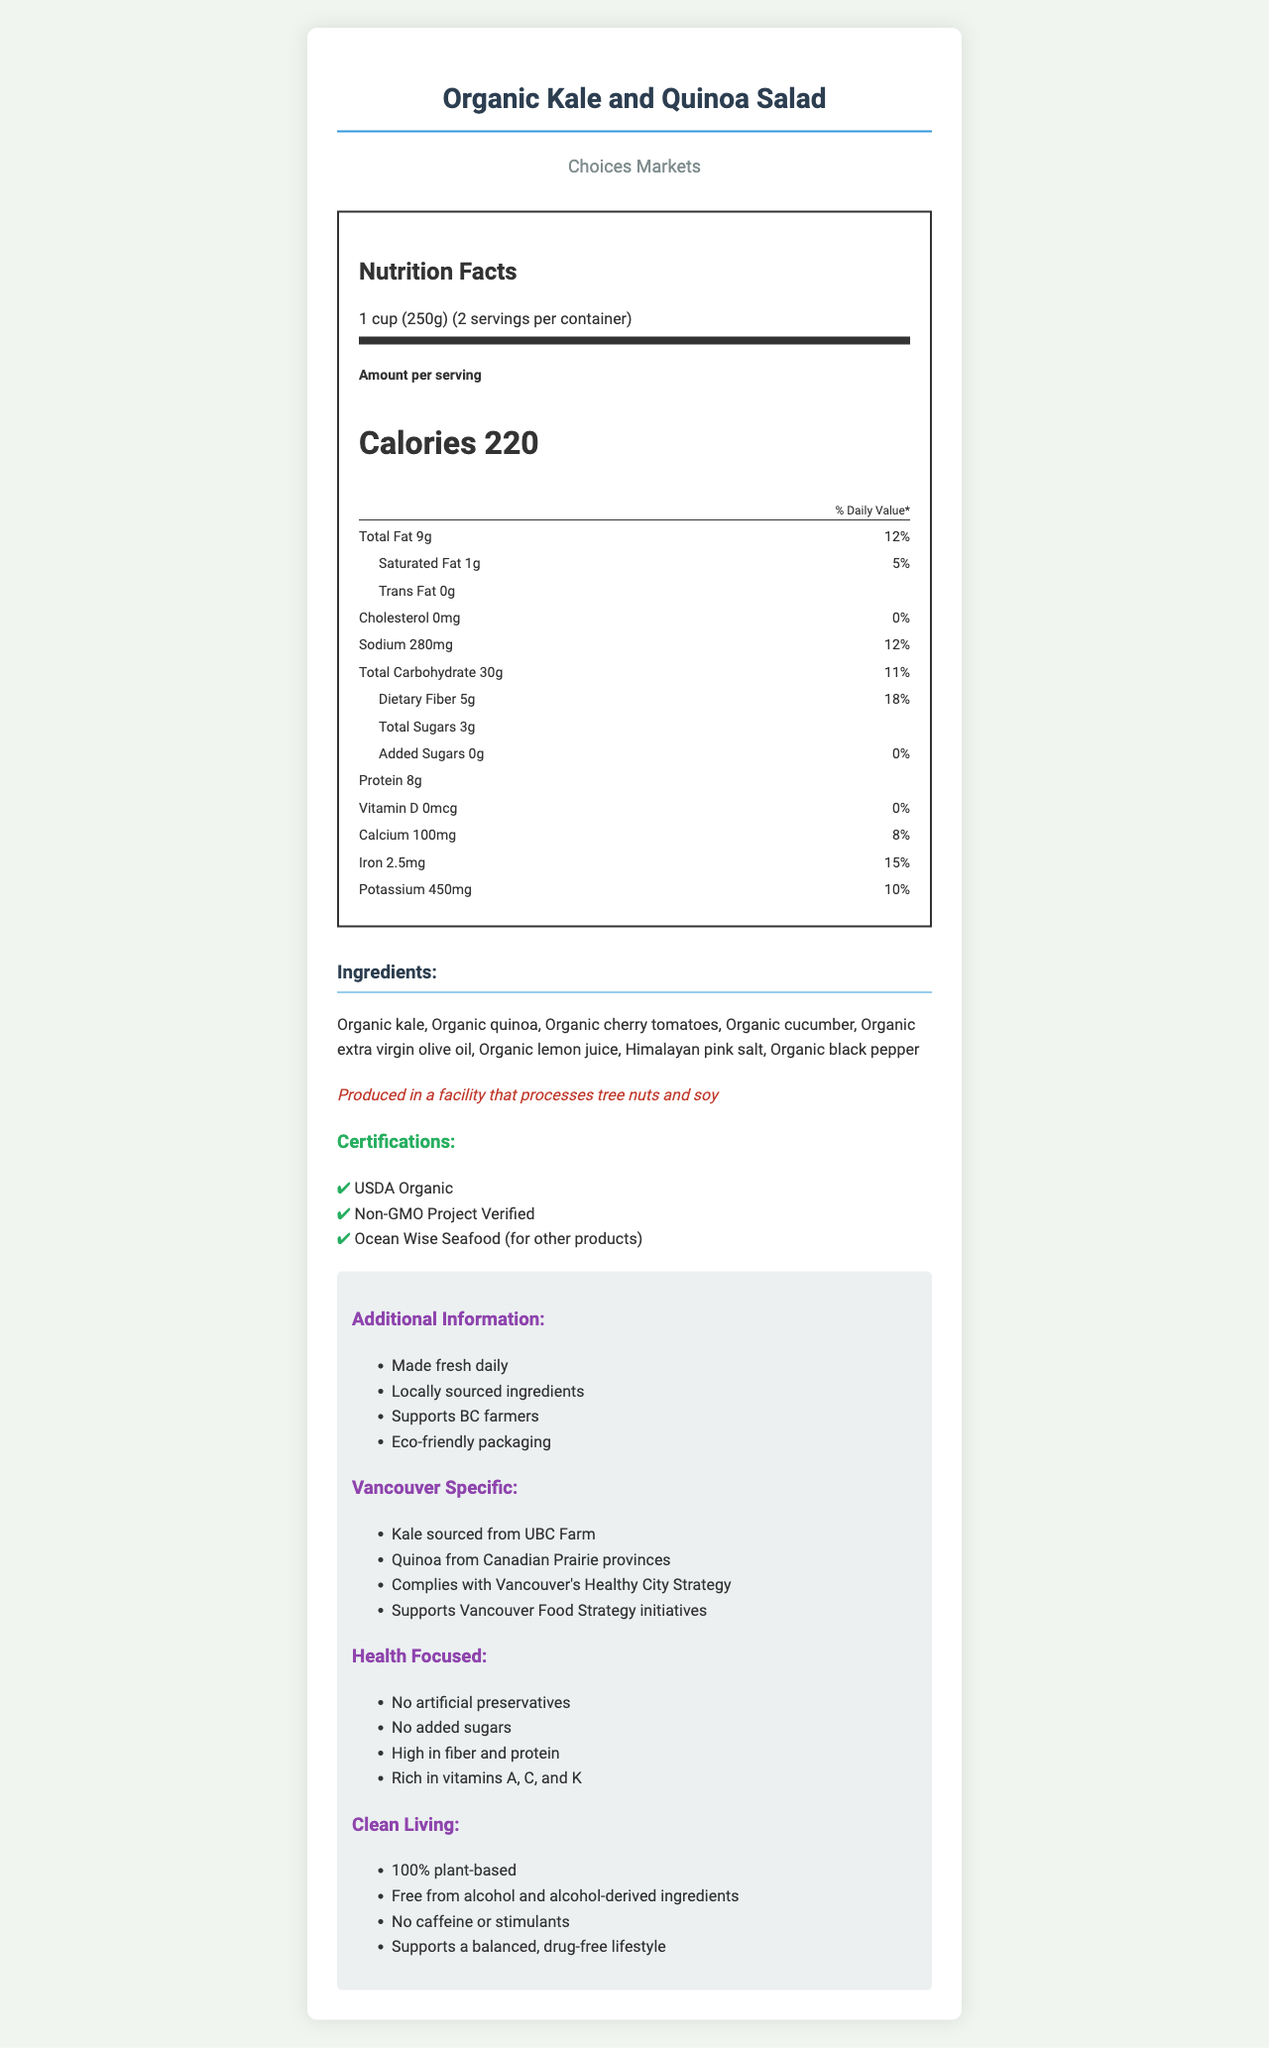what is the serving size? The document specifies the serving size under the nutrition label section.
Answer: 1 cup (250g) how many servings are there per container? Under the nutrition label section, it mentions servings per container as 2.
Answer: 2 what is the total fat content per serving? The nutrient detail for Total Fat is listed as 9 grams per serving.
Answer: 9g how much dietary fiber is in one serving? The nutrient detail for Dietary Fiber is listed as 5 grams per serving.
Answer: 5g which certification(s) does this product have? These certifications are listed in the certifications section.
Answer: USDA Organic, Non-GMO Project Verified, Ocean Wise Seafood (for other products) what is the sodium content per serving? The nutrient detail for Sodium is listed as 280 milligrams per serving.
Answer: 280mg what percentage of the daily value of iron does this salad provide? The document lists iron as providing 15% of the daily value per serving.
Answer: 15% does this product contain any added sugars? According to the nutrient details, the amount of added sugars is 0 grams and 0% daily value.
Answer: No where is the kale in the salad sourced from? A. BC Farms B. UBC Farm C. Canadian Prairie provinces D. Local markets The document states that the kale is sourced from UBC Farm under the Vancouver Specific section.
Answer: B which of the following ingredients is not part of the salad? 1. Organic kale 2. Organic quinoa 3. Organic sunflower seeds 4. Organic cherry tomatoes Sunflower seeds are not listed in the ingredients section.
Answer: 3 is this product suitable for a drug-free lifestyle? Under the clean living section, it mentions that the product supports a balanced, drug-free lifestyle and it is free from alcohol and alcohol-derived ingredients.
Answer: Yes summarize the main idea of the document The document describes the nutritional content, ingredients list, allergen information, certifications, and various attributes emphasizing health, local sourcing, and support for a drug-free lifestyle.
Answer: The document provides nutritional information, ingredients, certifications, and additional information for the Organic Kale and Quinoa Salad from Choices Markets. It highlights the product's health benefits, local sourcing, and commitment to clean living. how many calories are there per serving? The document clearly lists 220 calories per serving under the nutrition facts.
Answer: 220 is there any cholesterol in this product? The nutrient details indicate 0 milligrams of cholesterol per serving.
Answer: No how much protein does one serving contain? The nutrient details indicate that each serving contains 8 grams of protein.
Answer: 8g who produces the salad? The store name, Choices Markets, is mentioned along with the product name at the top of the document.
Answer: Choices Markets what are the main components of the salad? The ingredients section provides a list of the main components of the salad.
Answer: Organic kale, organic quinoa, organic cherry tomatoes, organic cucumber, organic extra virgin olive oil, organic lemon juice, Himalayan pink salt, organic black pepper does the document specify how the product aligns with Vancouver's Healthy City Strategy? The Vancouver Specific section mentions that the product complies with Vancouver's Healthy City Strategy.
Answer: Yes what percentage of the daily value of calcium is provided by one serving of the salad? The nutrient details list calcium as providing 8% of the daily value per serving.
Answer: 8% how much potassium is in each serving? A. 100mg B. 280mg C. 450mg D. 500mg The nutrient details list potassium as 450 milligrams per serving.
Answer: C 